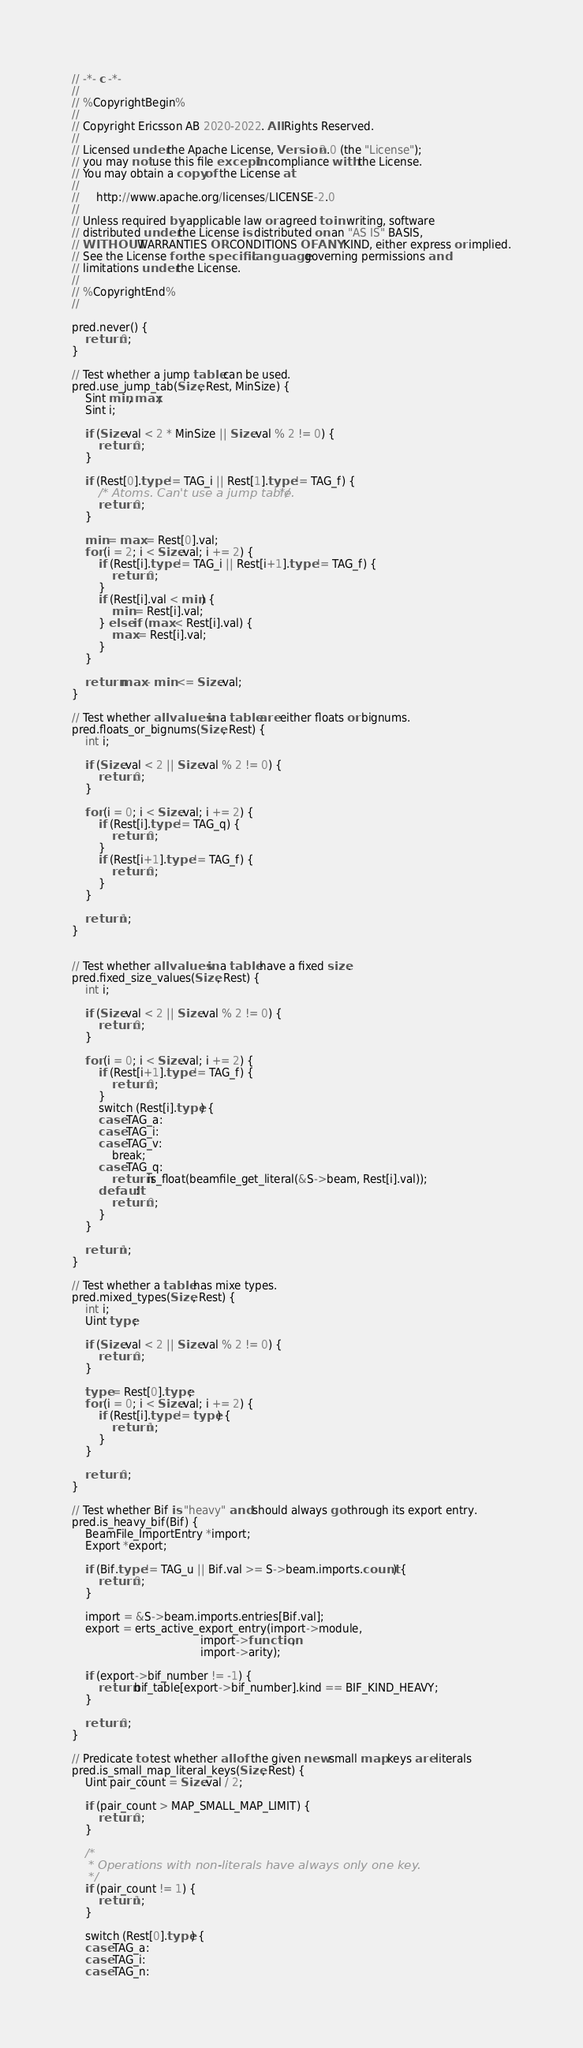<code> <loc_0><loc_0><loc_500><loc_500><_SQL_>// -*- c -*-
//
// %CopyrightBegin%
//
// Copyright Ericsson AB 2020-2022. All Rights Reserved.
//
// Licensed under the Apache License, Version 2.0 (the "License");
// you may not use this file except in compliance with the License.
// You may obtain a copy of the License at
//
//     http://www.apache.org/licenses/LICENSE-2.0
//
// Unless required by applicable law or agreed to in writing, software
// distributed under the License is distributed on an "AS IS" BASIS,
// WITHOUT WARRANTIES OR CONDITIONS OF ANY KIND, either express or implied.
// See the License for the specific language governing permissions and
// limitations under the License.
//
// %CopyrightEnd%
//

pred.never() {
    return 0;
}

// Test whether a jump table can be used.
pred.use_jump_tab(Size, Rest, MinSize) {
    Sint min, max;
    Sint i;

    if (Size.val < 2 * MinSize || Size.val % 2 != 0) {
        return 0;
    }

    if (Rest[0].type != TAG_i || Rest[1].type != TAG_f) {
        /* Atoms. Can't use a jump table. */
        return 0;
    }

    min = max = Rest[0].val;
    for (i = 2; i < Size.val; i += 2) {
        if (Rest[i].type != TAG_i || Rest[i+1].type != TAG_f) {
            return 0;
        }
        if (Rest[i].val < min) {
            min = Rest[i].val;
        } else if (max < Rest[i].val) {
            max = Rest[i].val;
        }
    }

    return max - min <= Size.val;
}

// Test whether all values in a table are either floats or bignums.
pred.floats_or_bignums(Size, Rest) {
    int i;

    if (Size.val < 2 || Size.val % 2 != 0) {
        return 0;
    }

    for (i = 0; i < Size.val; i += 2) {
        if (Rest[i].type != TAG_q) {
            return 0;
        }
        if (Rest[i+1].type != TAG_f) {
            return 0;
        }
    }

    return 1;
}


// Test whether all values in a table have a fixed size.
pred.fixed_size_values(Size, Rest) {
    int i;

    if (Size.val < 2 || Size.val % 2 != 0) {
        return 0;
    }

    for (i = 0; i < Size.val; i += 2) {
        if (Rest[i+1].type != TAG_f) {
            return 0;
        }
        switch (Rest[i].type) {
        case TAG_a:
        case TAG_i:
        case TAG_v:
            break;
        case TAG_q:
            return is_float(beamfile_get_literal(&S->beam, Rest[i].val));
        default:
            return 0;
        }
    }

    return 1;
}

// Test whether a table has mixe types.
pred.mixed_types(Size, Rest) {
    int i;
    Uint type;

    if (Size.val < 2 || Size.val % 2 != 0) {
        return 0;
    }

    type = Rest[0].type;
    for (i = 0; i < Size.val; i += 2) {
        if (Rest[i].type != type) {
            return 1;
        }
    }

    return 0;
}

// Test whether Bif is "heavy" and should always go through its export entry.
pred.is_heavy_bif(Bif) {
    BeamFile_ImportEntry *import;
    Export *export;

    if (Bif.type != TAG_u || Bif.val >= S->beam.imports.count) {
        return 0;
    }

    import = &S->beam.imports.entries[Bif.val];
    export = erts_active_export_entry(import->module,
                                      import->function,
                                      import->arity);

    if (export->bif_number != -1) {
        return bif_table[export->bif_number].kind == BIF_KIND_HEAVY;
    }

    return 0;
}

// Predicate to test whether all of the given new small map keys are literals
pred.is_small_map_literal_keys(Size, Rest) {
    Uint pair_count = Size.val / 2;

    if (pair_count > MAP_SMALL_MAP_LIMIT) {
        return 0;
    }

    /*
     * Operations with non-literals have always only one key.
     */
    if (pair_count != 1) {
        return 1;
    }

    switch (Rest[0].type) {
    case TAG_a:
    case TAG_i:
    case TAG_n:</code> 